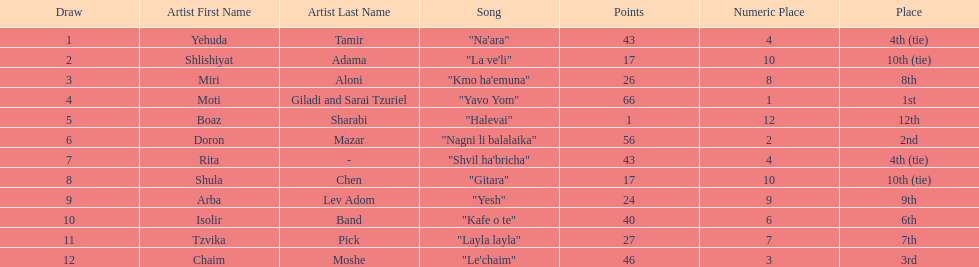Did the song "gitara" or "yesh" earn more points? "Yesh". Could you parse the entire table? {'header': ['Draw', 'Artist First Name', 'Artist Last Name', 'Song', 'Points', 'Numeric Place', 'Place'], 'rows': [['1', 'Yehuda', 'Tamir', '"Na\'ara"', '43', '4', '4th (tie)'], ['2', 'Shlishiyat', 'Adama', '"La ve\'li"', '17', '10', '10th (tie)'], ['3', 'Miri', 'Aloni', '"Kmo ha\'emuna"', '26', '8', '8th'], ['4', 'Moti', 'Giladi and Sarai Tzuriel', '"Yavo Yom"', '66', '1', '1st'], ['5', 'Boaz', 'Sharabi', '"Halevai"', '1', '12', '12th'], ['6', 'Doron', 'Mazar', '"Nagni li balalaika"', '56', '2', '2nd'], ['7', 'Rita', '-', '"Shvil ha\'bricha"', '43', '4', '4th (tie)'], ['8', 'Shula', 'Chen', '"Gitara"', '17', '10', '10th (tie)'], ['9', 'Arba', 'Lev Adom', '"Yesh"', '24', '9', '9th'], ['10', 'Isolir', 'Band', '"Kafe o te"', '40', '6', '6th'], ['11', 'Tzvika', 'Pick', '"Layla layla"', '27', '7', '7th'], ['12', 'Chaim', 'Moshe', '"Le\'chaim"', '46', '3', '3rd']]} 